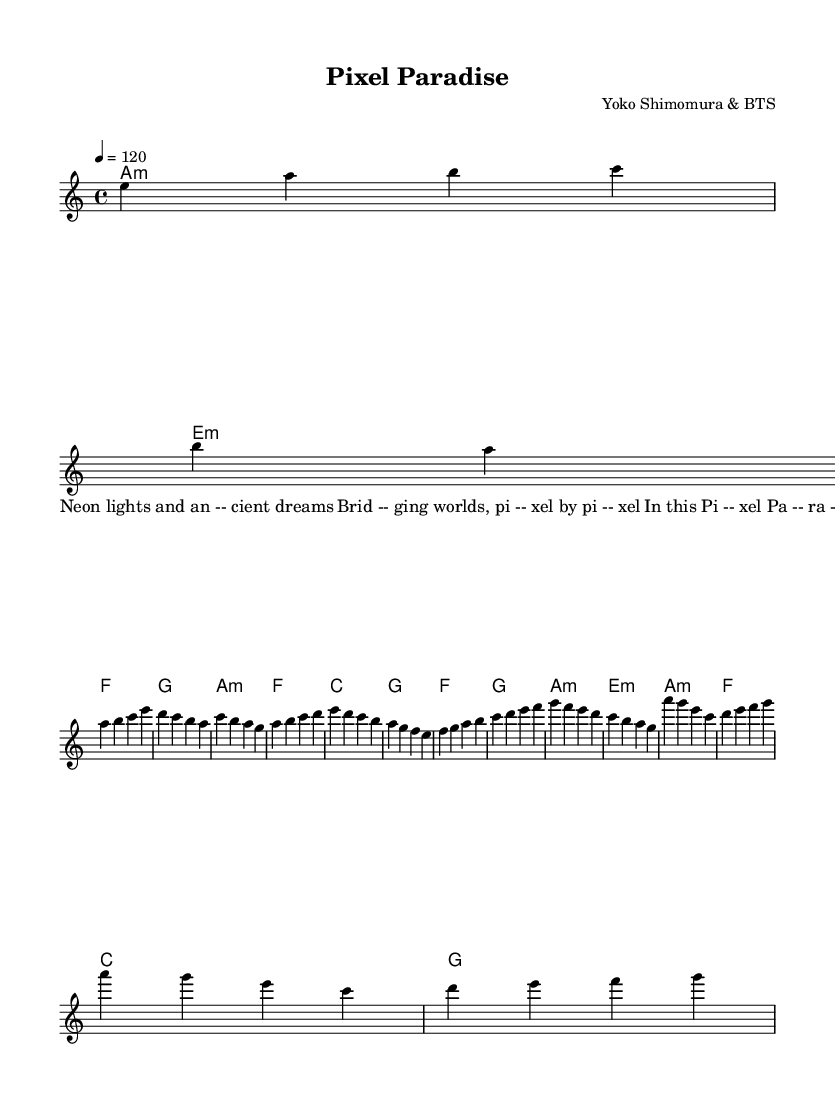What is the title of this piece? The title can be found in the header section of the sheet music, which states "Pixel Paradise."
Answer: Pixel Paradise What is the key signature of this music? The key signature is indicated in the global music section, which shows it is in A minor, which has no sharps or flats.
Answer: A minor What is the time signature of this music? The time signature is also included in the global section, displaying a 4/4 time signature.
Answer: 4/4 What is the tempo marking for this piece? The tempo is stated in the global section as "4 = 120," meaning there are 120 beats per minute.
Answer: 120 How many measures are there in the chorus section? Counting the measures in the chorus section from the given melody, there are four measures in total.
Answer: 4 What is the first lyric line of the verse? The first lyric line is located within the verse section of the lyrics, stating "Neon lights and an -- cient dreams."
Answer: Neon lights and ancient dreams Which two composers collaborated on this piece? The composer information in the header lists Yoko Shimomura and BTS as the creators of this piece.
Answer: Yoko Shimomura & BTS 